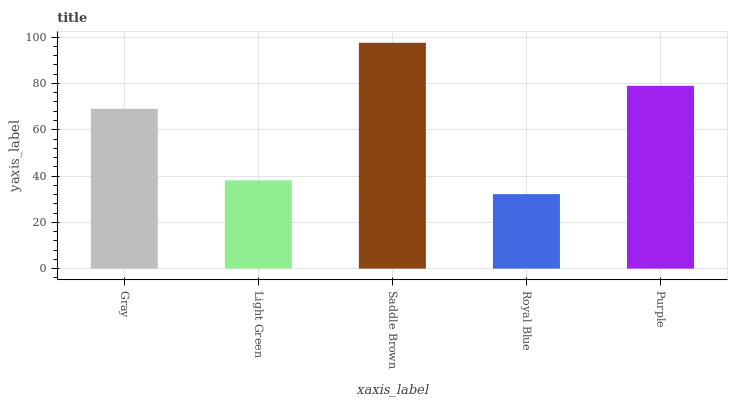Is Royal Blue the minimum?
Answer yes or no. Yes. Is Saddle Brown the maximum?
Answer yes or no. Yes. Is Light Green the minimum?
Answer yes or no. No. Is Light Green the maximum?
Answer yes or no. No. Is Gray greater than Light Green?
Answer yes or no. Yes. Is Light Green less than Gray?
Answer yes or no. Yes. Is Light Green greater than Gray?
Answer yes or no. No. Is Gray less than Light Green?
Answer yes or no. No. Is Gray the high median?
Answer yes or no. Yes. Is Gray the low median?
Answer yes or no. Yes. Is Purple the high median?
Answer yes or no. No. Is Saddle Brown the low median?
Answer yes or no. No. 